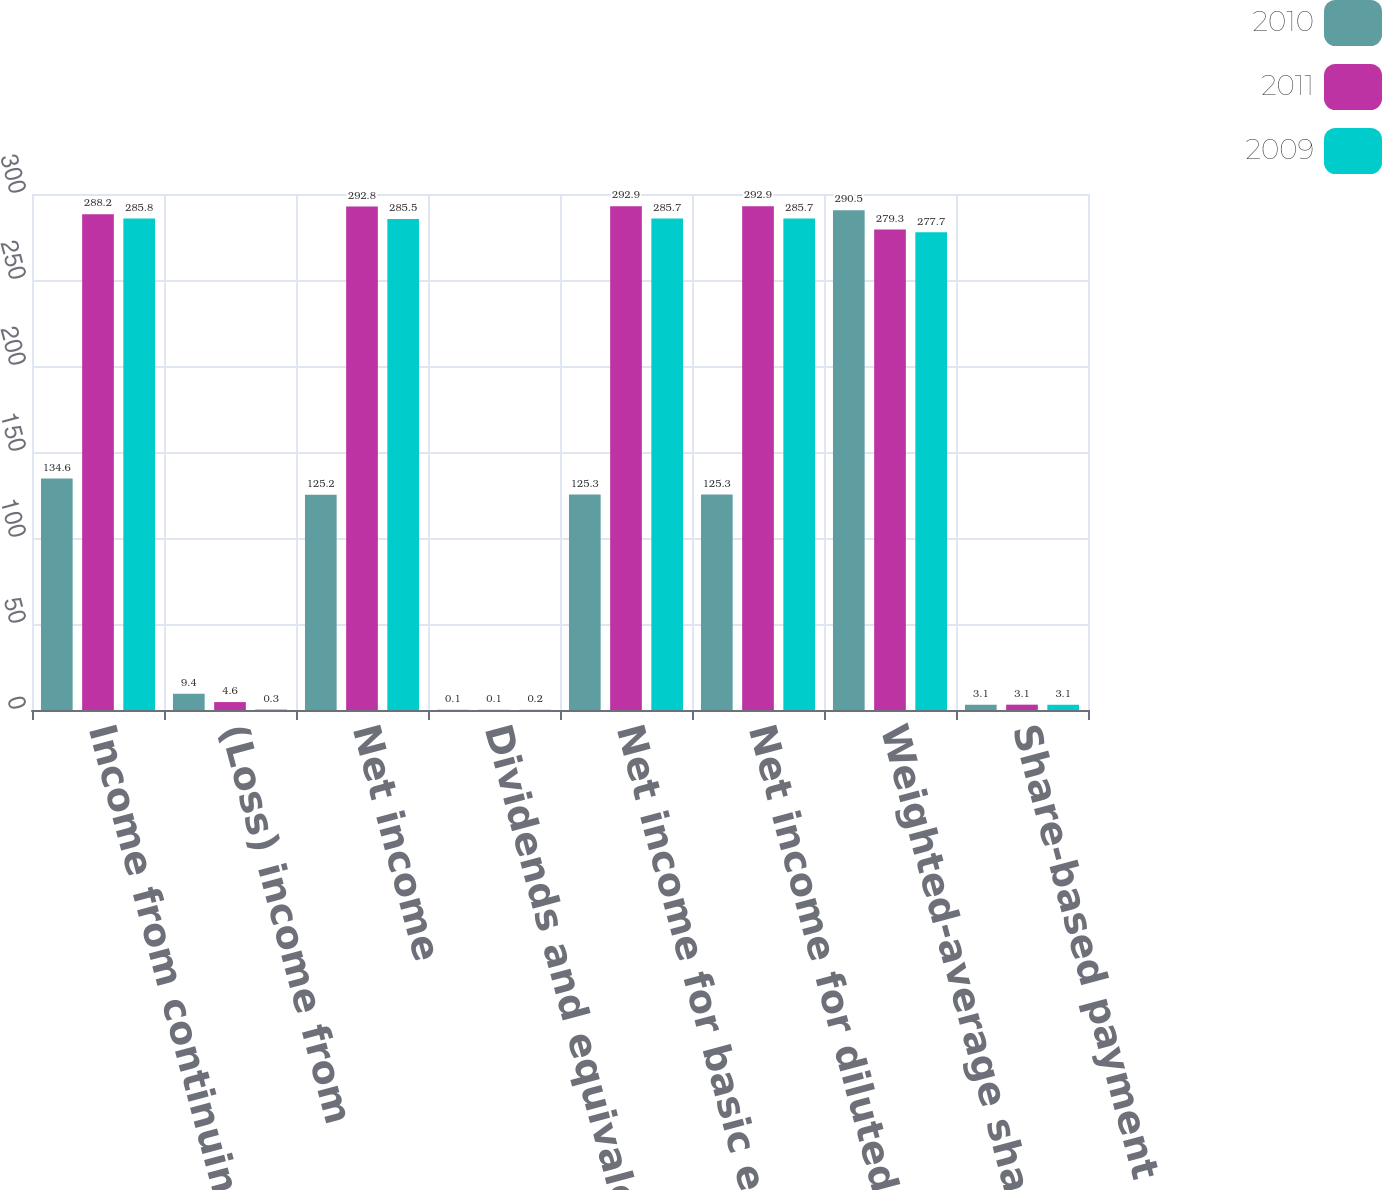Convert chart to OTSL. <chart><loc_0><loc_0><loc_500><loc_500><stacked_bar_chart><ecel><fcel>Income from continuing<fcel>(Loss) income from<fcel>Net income<fcel>Dividends and equivalents for<fcel>Net income for basic earnings<fcel>Net income for diluted<fcel>Weighted-average shares<fcel>Share-based payment awards<nl><fcel>2010<fcel>134.6<fcel>9.4<fcel>125.2<fcel>0.1<fcel>125.3<fcel>125.3<fcel>290.5<fcel>3.1<nl><fcel>2011<fcel>288.2<fcel>4.6<fcel>292.8<fcel>0.1<fcel>292.9<fcel>292.9<fcel>279.3<fcel>3.1<nl><fcel>2009<fcel>285.8<fcel>0.3<fcel>285.5<fcel>0.2<fcel>285.7<fcel>285.7<fcel>277.7<fcel>3.1<nl></chart> 